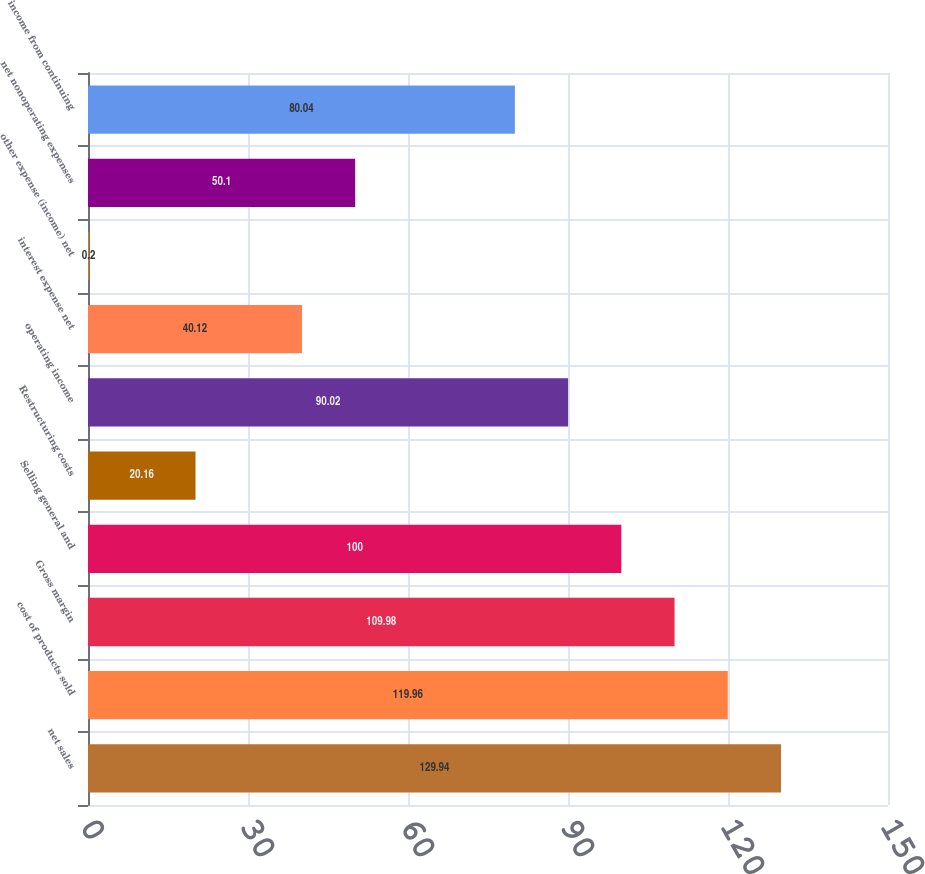<chart> <loc_0><loc_0><loc_500><loc_500><bar_chart><fcel>net sales<fcel>cost of products sold<fcel>Gross margin<fcel>Selling general and<fcel>Restructuring costs<fcel>operating income<fcel>interest expense net<fcel>other expense (income) net<fcel>net nonoperating expenses<fcel>income from continuing<nl><fcel>129.94<fcel>119.96<fcel>109.98<fcel>100<fcel>20.16<fcel>90.02<fcel>40.12<fcel>0.2<fcel>50.1<fcel>80.04<nl></chart> 